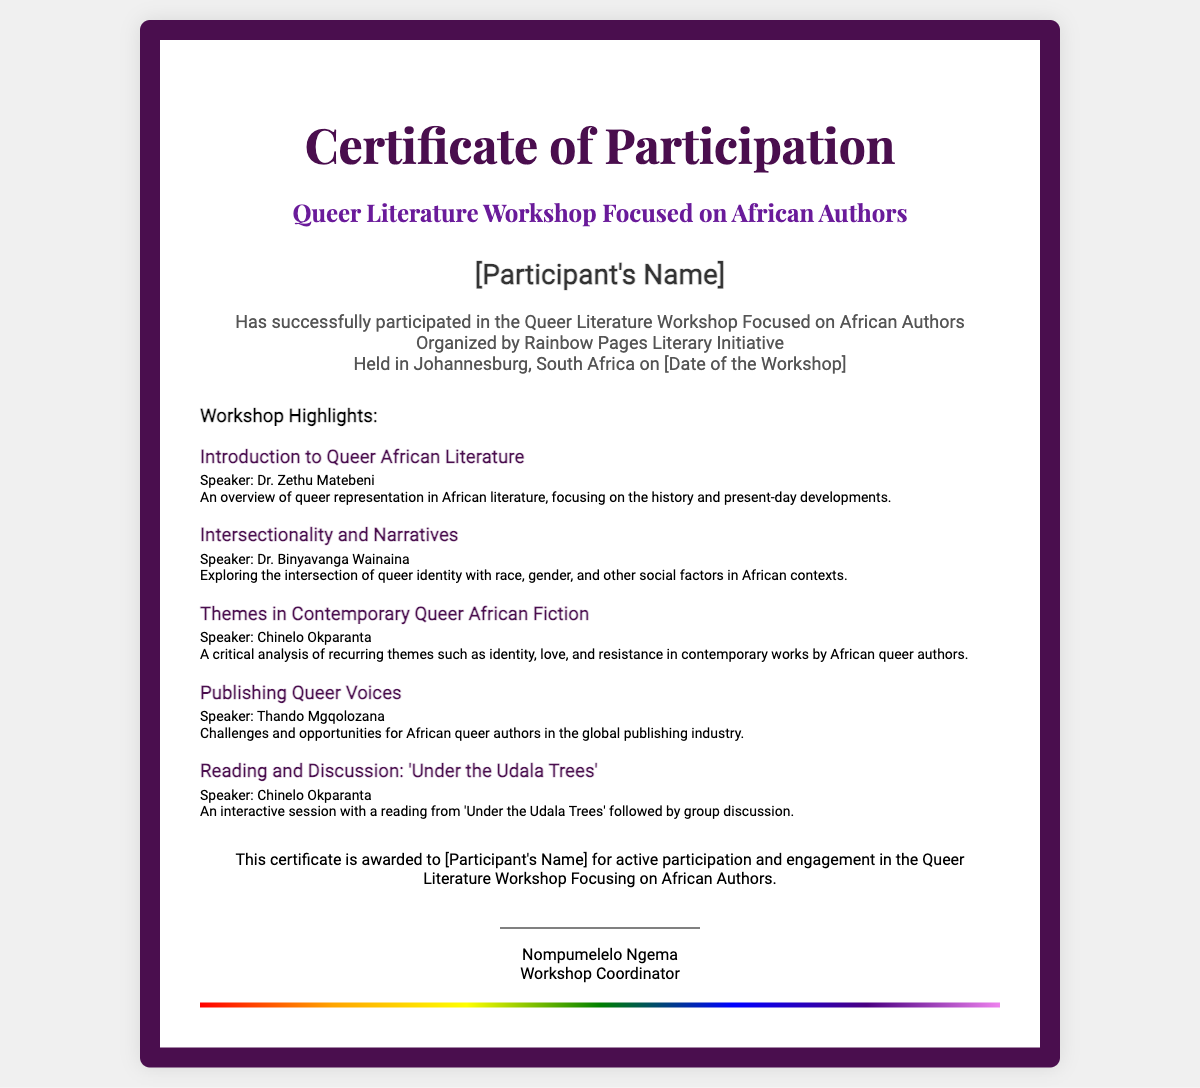What is the title of the workshop? The title of the workshop is prominently shown in the document under the main heading.
Answer: Queer Literature Workshop Focused on African Authors Who organized the workshop? The organization responsible for the workshop is mentioned in the details section of the certificate.
Answer: Rainbow Pages Literary Initiative Where was the workshop held? The location of the workshop is specified in the details section of the document.
Answer: Johannesburg, South Africa Who was the speaker for 'Introduction to Queer African Literature'? The speaker's name for the specific session is provided in the workshop highlights.
Answer: Dr. Zethu Matebeni What is one of the key themes discussed in the workshop? Themes discussed in the workshop can be found in the highlights section of the document.
Answer: Identity, love, and resistance What type of certificate is this document? The type of certificate is indicated at the very top of the document.
Answer: Certificate of Participation Who is the workshop coordinator? The name of the coordinator is found at the bottom of the certificate.
Answer: Nompumelelo Ngema What interactive activity took place during the workshop? The specific interactive activity is mentioned among the highlights related to a reading and discussion.
Answer: Reading and Discussion: 'Under the Udala Trees' What is the date of the workshop? The date is a placeholder mentioned in the details section, indicating it should be filled in.
Answer: [Date of the Workshop] 